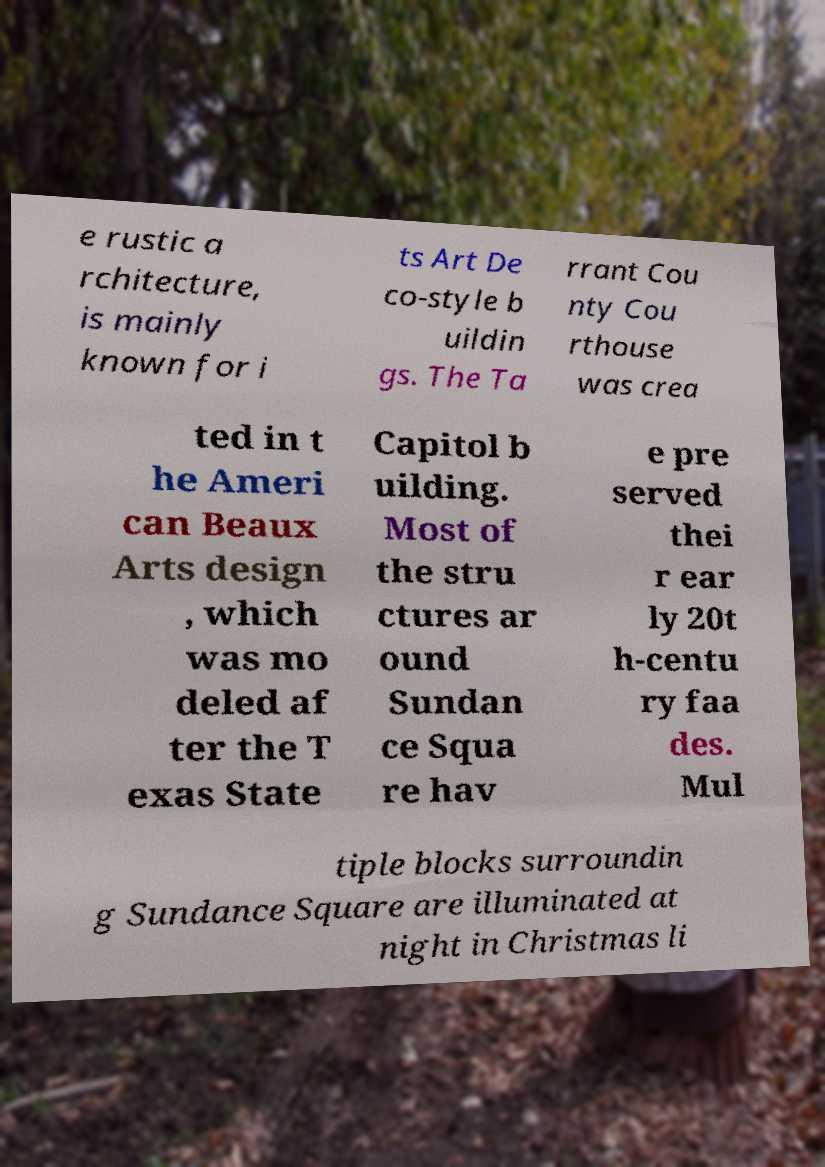Please identify and transcribe the text found in this image. e rustic a rchitecture, is mainly known for i ts Art De co-style b uildin gs. The Ta rrant Cou nty Cou rthouse was crea ted in t he Ameri can Beaux Arts design , which was mo deled af ter the T exas State Capitol b uilding. Most of the stru ctures ar ound Sundan ce Squa re hav e pre served thei r ear ly 20t h-centu ry faa des. Mul tiple blocks surroundin g Sundance Square are illuminated at night in Christmas li 